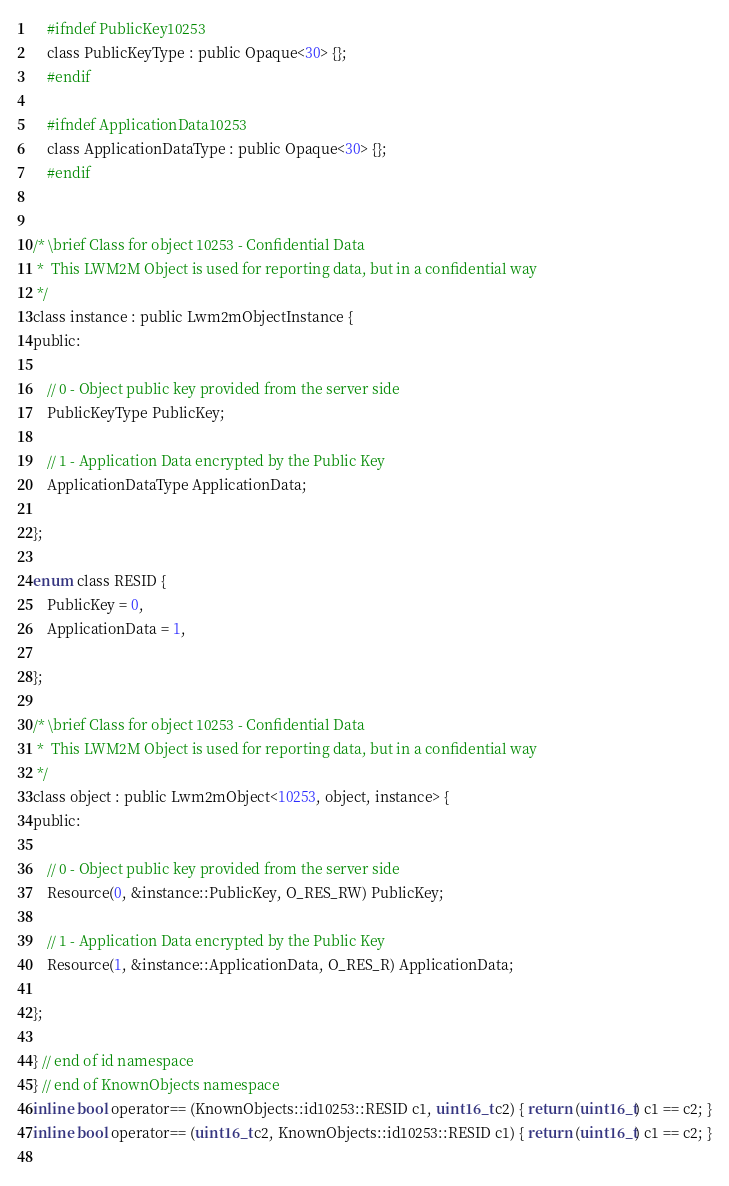<code> <loc_0><loc_0><loc_500><loc_500><_C_>    #ifndef PublicKey10253
    class PublicKeyType : public Opaque<30> {};
    #endif
    
    #ifndef ApplicationData10253
    class ApplicationDataType : public Opaque<30> {};
    #endif
    

/* \brief Class for object 10253 - Confidential Data
 *  This LWM2M Object is used for reporting data, but in a confidential way
 */
class instance : public Lwm2mObjectInstance {
public:

    // 0 - Object public key provided from the server side
    PublicKeyType PublicKey;
    
    // 1 - Application Data encrypted by the Public Key
    ApplicationDataType ApplicationData;
    
};

enum class RESID {
    PublicKey = 0,
    ApplicationData = 1,
    
};

/* \brief Class for object 10253 - Confidential Data
 *  This LWM2M Object is used for reporting data, but in a confidential way
 */
class object : public Lwm2mObject<10253, object, instance> {
public:

    // 0 - Object public key provided from the server side
    Resource(0, &instance::PublicKey, O_RES_RW) PublicKey;
    
    // 1 - Application Data encrypted by the Public Key
    Resource(1, &instance::ApplicationData, O_RES_R) ApplicationData;
    
};

} // end of id namespace
} // end of KnownObjects namespace
inline bool operator== (KnownObjects::id10253::RESID c1, uint16_t c2) { return (uint16_t) c1 == c2; }
inline bool operator== (uint16_t c2, KnownObjects::id10253::RESID c1) { return (uint16_t) c1 == c2; }
	</code> 